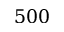Convert formula to latex. <formula><loc_0><loc_0><loc_500><loc_500>5 0 0</formula> 